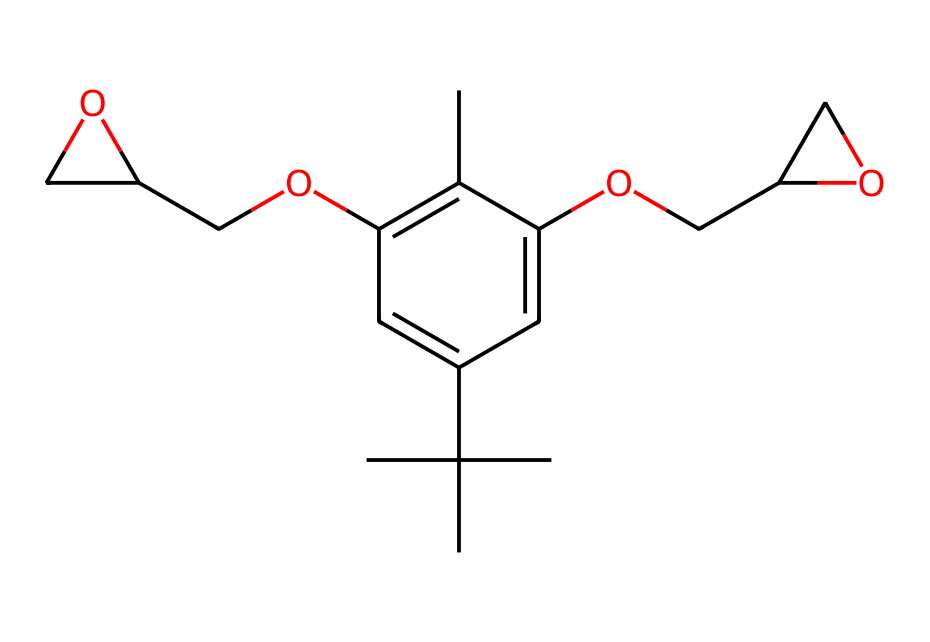How many carbon atoms are in this compound? By examining the SMILES representation, each "C" represents a carbon atom. Counting each "C" in the SMILES string gives a total of 15 carbon atoms.
Answer: 15 What functional groups are present in this chemical? In the structure, we can identify hydroxyl groups (-OH) indicated by the presence of "O" attached to carbon. There are two such groups in this compound, which suggest the presence of alcohol functional groups.
Answer: alcohol What is the degree of unsaturation in this compound? The degree of unsaturation can be determined by counting the double bonds and rings in the structure. In this case, there are two double bonds and no rings, leading to a degree of unsaturation of 2.
Answer: 2 Does this compound contain any cyclic structures? A cyclic structure is denoted by the presence of numbered atoms in the SMILES representation. Here, "C1" and the corresponding "C1" indicate that there is a ring structure present.
Answer: yes What type of polymer is formed from this resin? This compound typically leads to epoxy polymers upon curing, characterized by its ability to cross-link and form three-dimensional networks.
Answer: epoxy How many oxygen atoms are present in this molecule? By counting the "O" symbols in the SMILES notation, there are two oxygen atoms present in this compound.
Answer: 2 